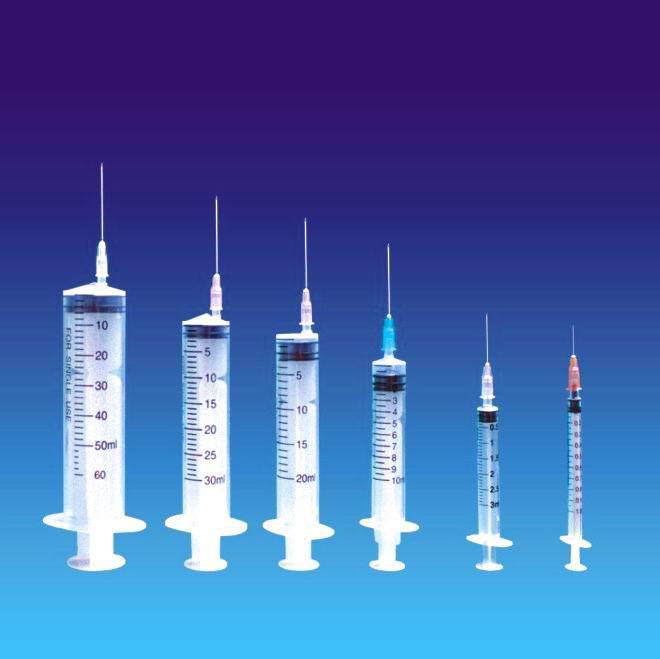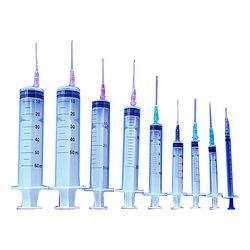The first image is the image on the left, the second image is the image on the right. Given the left and right images, does the statement "There are at least fourteen syringes with needle on them." hold true? Answer yes or no. Yes. The first image is the image on the left, the second image is the image on the right. For the images shown, is this caption "There are more than twelve syringes in total." true? Answer yes or no. Yes. 